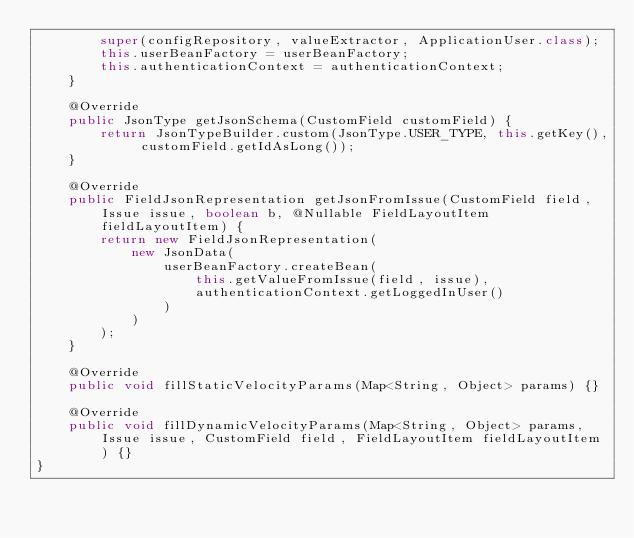Convert code to text. <code><loc_0><loc_0><loc_500><loc_500><_Java_>        super(configRepository, valueExtractor, ApplicationUser.class);
        this.userBeanFactory = userBeanFactory;
        this.authenticationContext = authenticationContext;
    }

    @Override
    public JsonType getJsonSchema(CustomField customField) {
        return JsonTypeBuilder.custom(JsonType.USER_TYPE, this.getKey(), customField.getIdAsLong());
    }

    @Override
    public FieldJsonRepresentation getJsonFromIssue(CustomField field, Issue issue, boolean b, @Nullable FieldLayoutItem fieldLayoutItem) {
        return new FieldJsonRepresentation(
            new JsonData(
                userBeanFactory.createBean(
                    this.getValueFromIssue(field, issue),
                    authenticationContext.getLoggedInUser()
                )
            )
        );
    }

    @Override
    public void fillStaticVelocityParams(Map<String, Object> params) {}

    @Override
    public void fillDynamicVelocityParams(Map<String, Object> params, Issue issue, CustomField field, FieldLayoutItem fieldLayoutItem) {}
}
</code> 